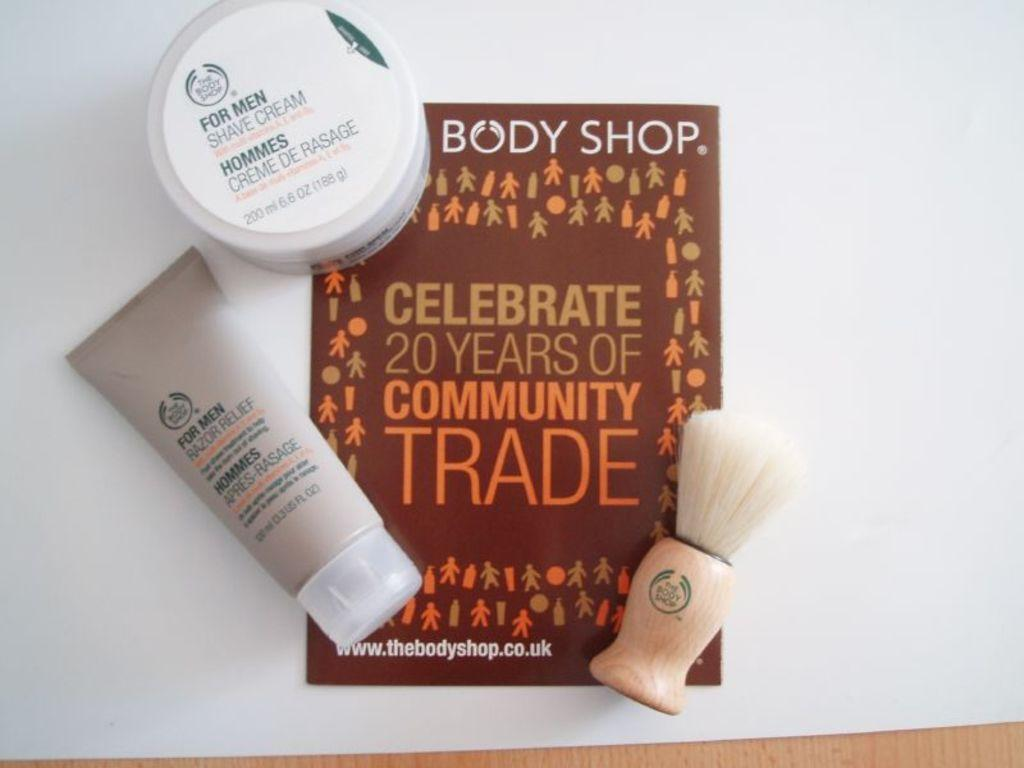<image>
Give a short and clear explanation of the subsequent image. A set of For Men Shave Cream and shaving brush 